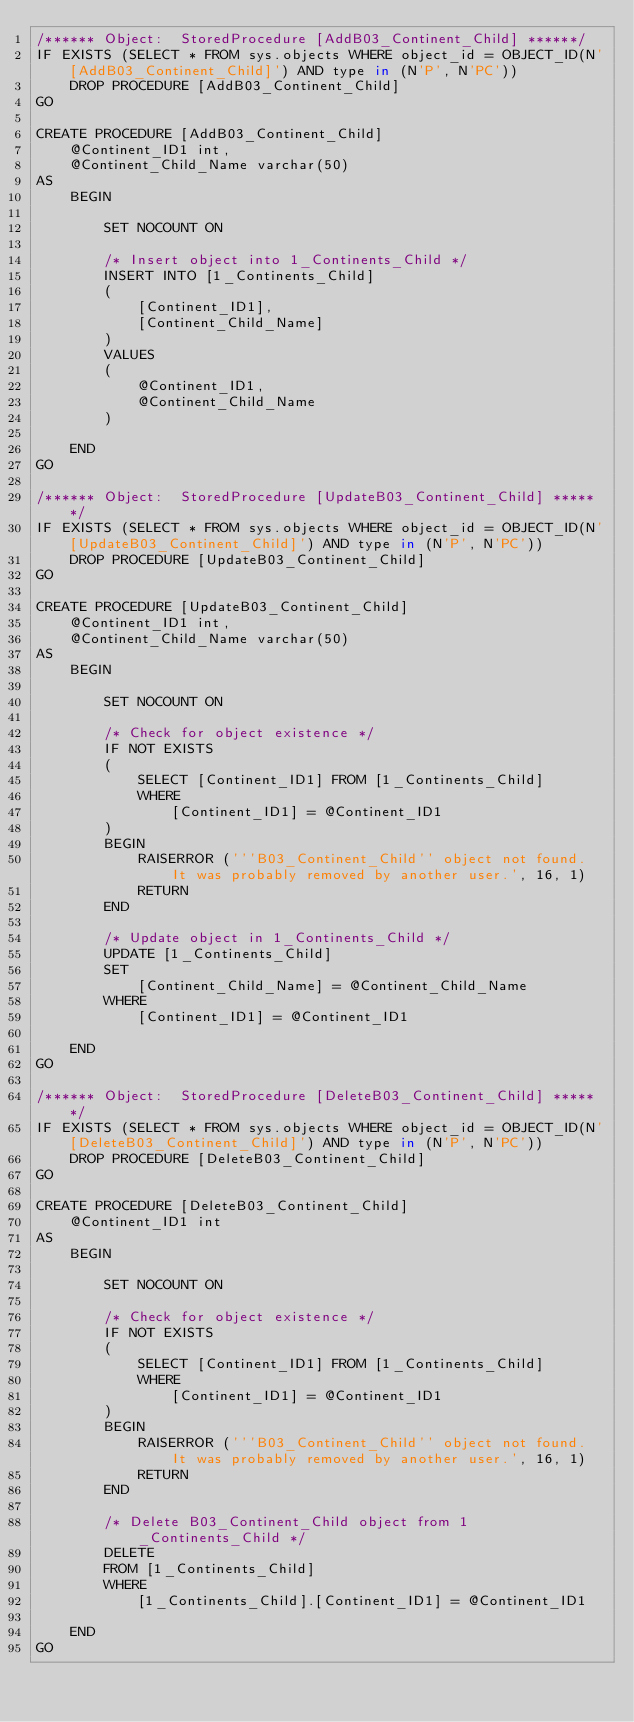<code> <loc_0><loc_0><loc_500><loc_500><_SQL_>/****** Object:  StoredProcedure [AddB03_Continent_Child] ******/
IF EXISTS (SELECT * FROM sys.objects WHERE object_id = OBJECT_ID(N'[AddB03_Continent_Child]') AND type in (N'P', N'PC'))
    DROP PROCEDURE [AddB03_Continent_Child]
GO

CREATE PROCEDURE [AddB03_Continent_Child]
    @Continent_ID1 int,
    @Continent_Child_Name varchar(50)
AS
    BEGIN

        SET NOCOUNT ON

        /* Insert object into 1_Continents_Child */
        INSERT INTO [1_Continents_Child]
        (
            [Continent_ID1],
            [Continent_Child_Name]
        )
        VALUES
        (
            @Continent_ID1,
            @Continent_Child_Name
        )

    END
GO

/****** Object:  StoredProcedure [UpdateB03_Continent_Child] ******/
IF EXISTS (SELECT * FROM sys.objects WHERE object_id = OBJECT_ID(N'[UpdateB03_Continent_Child]') AND type in (N'P', N'PC'))
    DROP PROCEDURE [UpdateB03_Continent_Child]
GO

CREATE PROCEDURE [UpdateB03_Continent_Child]
    @Continent_ID1 int,
    @Continent_Child_Name varchar(50)
AS
    BEGIN

        SET NOCOUNT ON

        /* Check for object existence */
        IF NOT EXISTS
        (
            SELECT [Continent_ID1] FROM [1_Continents_Child]
            WHERE
                [Continent_ID1] = @Continent_ID1
        )
        BEGIN
            RAISERROR ('''B03_Continent_Child'' object not found. It was probably removed by another user.', 16, 1)
            RETURN
        END

        /* Update object in 1_Continents_Child */
        UPDATE [1_Continents_Child]
        SET
            [Continent_Child_Name] = @Continent_Child_Name
        WHERE
            [Continent_ID1] = @Continent_ID1

    END
GO

/****** Object:  StoredProcedure [DeleteB03_Continent_Child] ******/
IF EXISTS (SELECT * FROM sys.objects WHERE object_id = OBJECT_ID(N'[DeleteB03_Continent_Child]') AND type in (N'P', N'PC'))
    DROP PROCEDURE [DeleteB03_Continent_Child]
GO

CREATE PROCEDURE [DeleteB03_Continent_Child]
    @Continent_ID1 int
AS
    BEGIN

        SET NOCOUNT ON

        /* Check for object existence */
        IF NOT EXISTS
        (
            SELECT [Continent_ID1] FROM [1_Continents_Child]
            WHERE
                [Continent_ID1] = @Continent_ID1
        )
        BEGIN
            RAISERROR ('''B03_Continent_Child'' object not found. It was probably removed by another user.', 16, 1)
            RETURN
        END

        /* Delete B03_Continent_Child object from 1_Continents_Child */
        DELETE
        FROM [1_Continents_Child]
        WHERE
            [1_Continents_Child].[Continent_ID1] = @Continent_ID1

    END
GO
</code> 